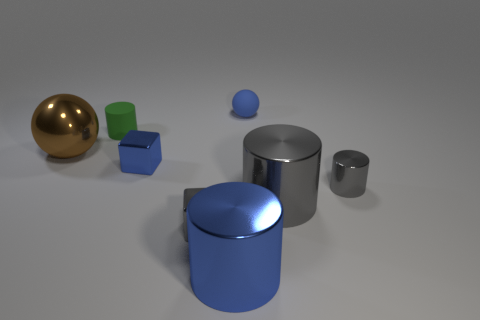What is the color composition of this scene? The scene has a rather simple color composition, featuring primarily cool tones. There's a strong presence of blue observed in two of the objects - a shiny small sphere and a larger cylinder. Contrasting this cool dominance, there is one object in a warm, gold hue—a large sphere. The remaining objects include a green cube, a silver cylinder, and a smaller gray cylinder. The background itself is neutral, which allows the colors of the objects to stand out more prominently. 